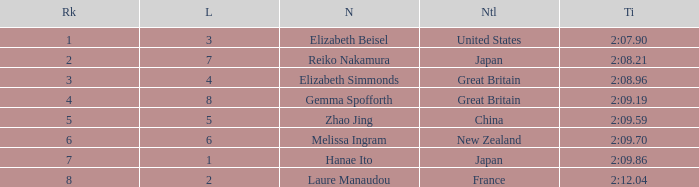What is Elizabeth Simmonds' average lane number? 4.0. 